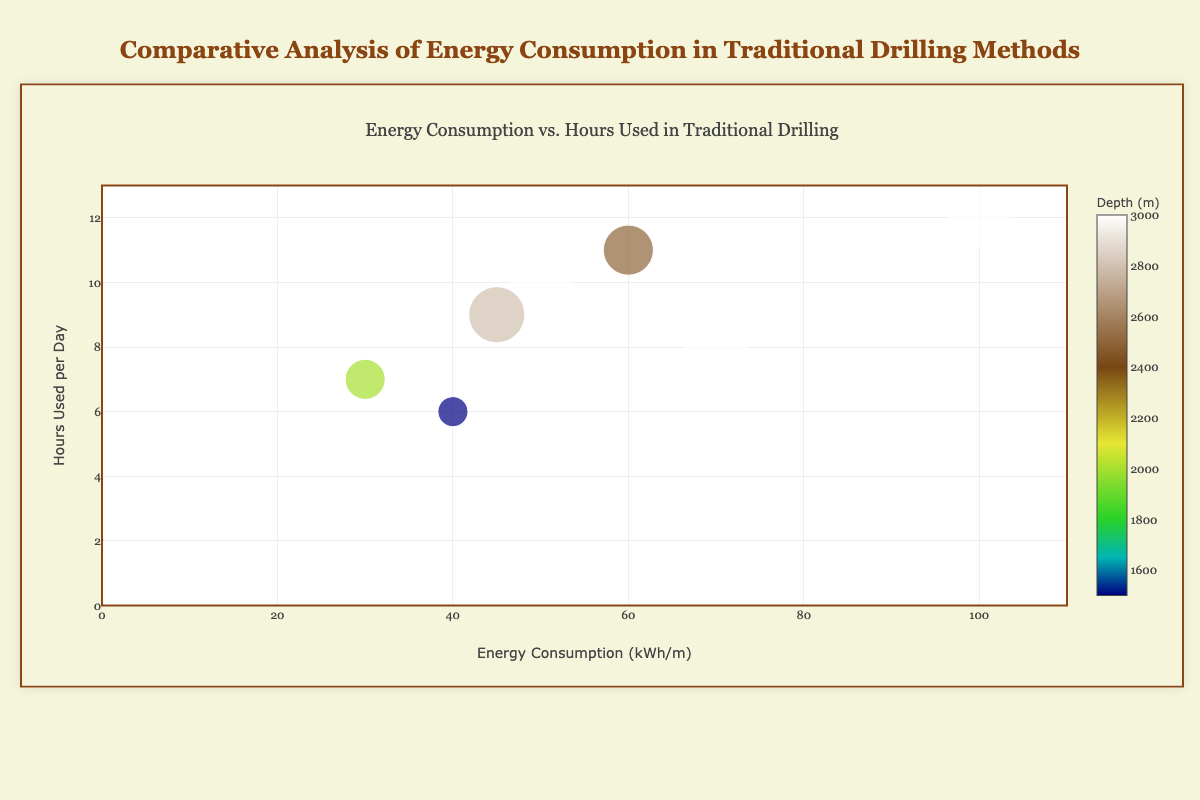What is the title of the chart? The title is located at the top of the chart and reads "Energy Consumption vs. Hours Used in Traditional Drilling."
Answer: Energy Consumption vs. Hours Used in Traditional Drilling How many different equipment types are represented on the chart? The legend of the chart shows the names of the equipment types, and by counting them, we see there are 7 distinct types.
Answer: 7 Which equipment type has the highest energy consumption per meter? By looking at the size and position of the bubbles on the x-axis, the "Generator" stands out as the one with the highest energy consumption at 100 kWh/m.
Answer: Generator What is the depth value associated with the "Mud Pump"? Hovering over the "Mud Pump" bubble reveals that its depth is 3000 meters, as displayed on the hover label.
Answer: 3000 meters Which equipment type is used the most hours per day? By examining the y-axis, the "Generator" is positioned at the highest point, indicating it is used for 12 hours per day.
Answer: Generator What is the energy consumption range on the x-axis? The x-axis title "Energy Consumption (kWh/m)" shows a range from 0 to 110 kWh/m as indicated by the axis markers.
Answer: 0 to 110 kWh/m Which equipment type has the lowest energy consumption per meter and how much is it? By examining the far left on the x-axis and checking the hover label, "Shale Shaker" has the lowest consumption at 30 kWh/m.
Answer: Shale Shaker, 30 kWh/m What’s the average depth of all equipment types? Summing all depth values (3000 + 2800 + 3000 + 2500 + 2000 + 1500 + 3000) = 17800 meters, dividing by the number of equipment types (7), the average depth is 2542.86 meters.
Answer: 2542.86 meters Which type of equipment type is used for the least number of hours per day and what is its energy consumption per meter? By locating the lowest point on the y-axis and examining the hover label, "Blowout Preventer" is used for 6 hours per day and has an energy consumption of 40 kWh/m.
Answer: Blowout Preventer, 40 kWh/m How does the energy consumption for the "Top Drive" compare to the "Drawworks"? "Top Drive" has an energy consumption of 45 kWh/m whereas "Drawworks" has 60 kWh/m, finding that "Drawworks" has a higher energy consumption by 15 kWh/m.
Answer: Drawworks is higher by 15 kWh/m 